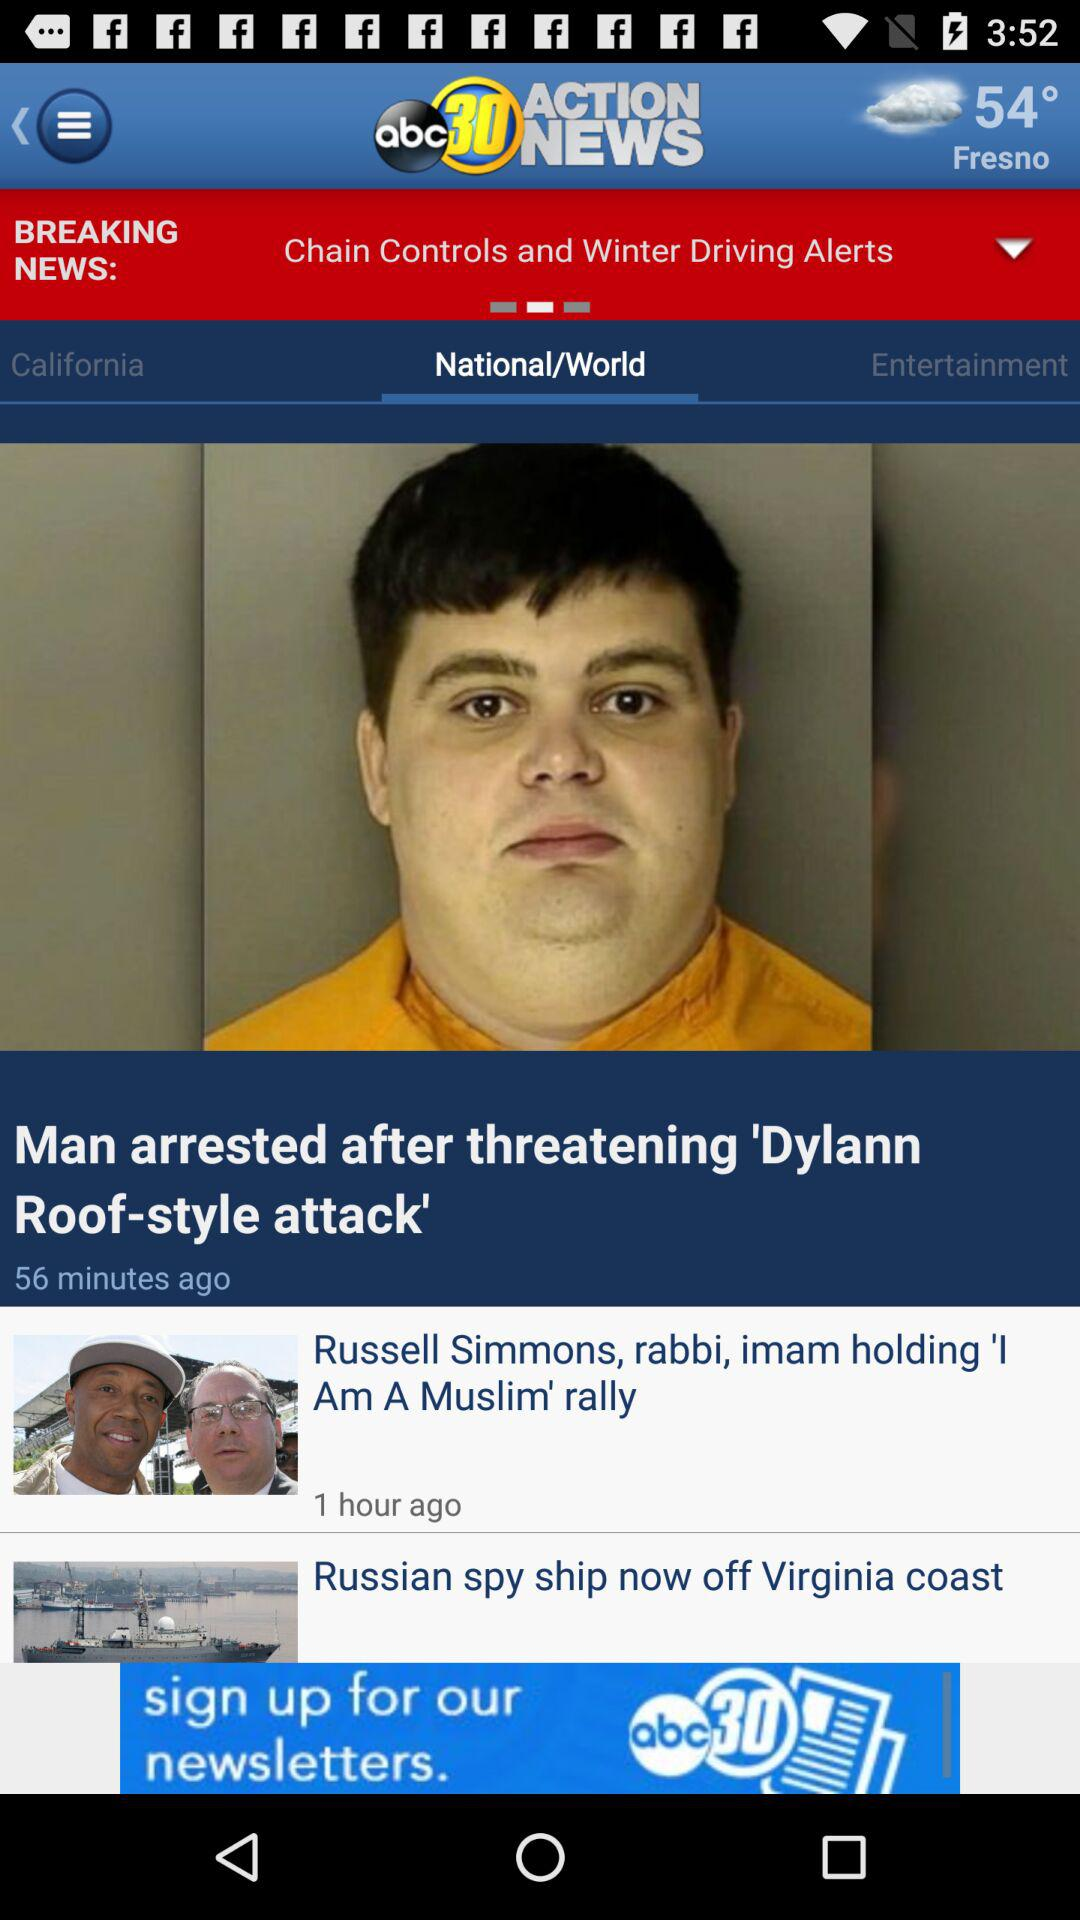What location's temperature is given? The location is Fresno. 